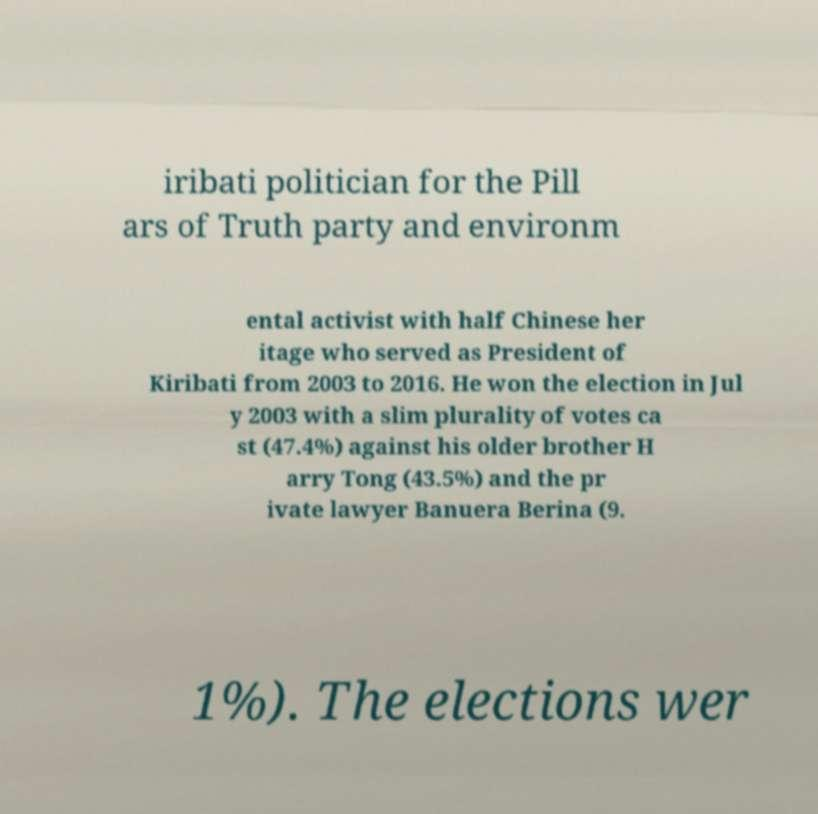For documentation purposes, I need the text within this image transcribed. Could you provide that? iribati politician for the Pill ars of Truth party and environm ental activist with half Chinese her itage who served as President of Kiribati from 2003 to 2016. He won the election in Jul y 2003 with a slim plurality of votes ca st (47.4%) against his older brother H arry Tong (43.5%) and the pr ivate lawyer Banuera Berina (9. 1%). The elections wer 